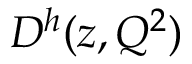Convert formula to latex. <formula><loc_0><loc_0><loc_500><loc_500>D ^ { h } ( z , Q ^ { 2 } )</formula> 